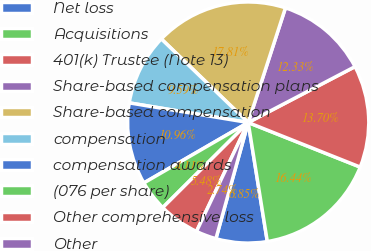<chart> <loc_0><loc_0><loc_500><loc_500><pie_chart><fcel>Net loss<fcel>Acquisitions<fcel>401(k) Trustee (Note 13)<fcel>Share-based compensation plans<fcel>Share-based compensation<fcel>compensation<fcel>compensation awards<fcel>(076 per share)<fcel>Other comprehensive loss<fcel>Other<nl><fcel>6.85%<fcel>16.44%<fcel>13.7%<fcel>12.33%<fcel>17.81%<fcel>9.59%<fcel>10.96%<fcel>4.11%<fcel>5.48%<fcel>2.74%<nl></chart> 